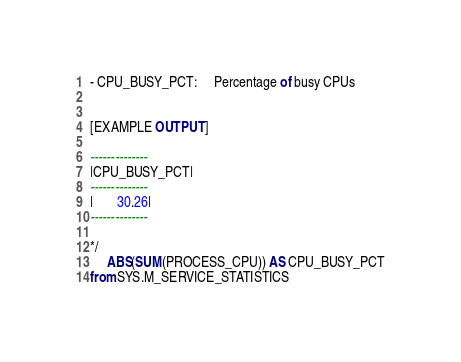<code> <loc_0><loc_0><loc_500><loc_500><_SQL_>
- CPU_BUSY_PCT:     Percentage of busy CPUs


[EXAMPLE OUTPUT]

--------------
|CPU_BUSY_PCT|
--------------
|       30.26|
--------------

*/
	 ABS(SUM(PROCESS_CPU)) AS CPU_BUSY_PCT
from SYS.M_SERVICE_STATISTICS
</code> 